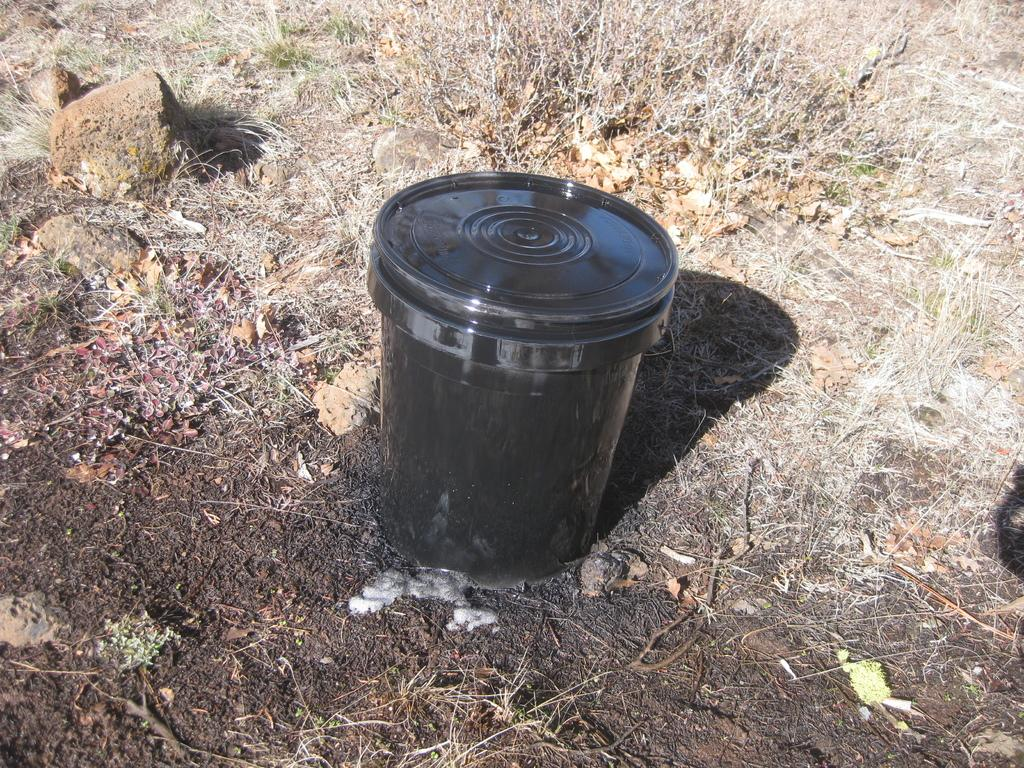What object is in the center of the image? There is a tube in the center of the image. Where is the tube positioned in the image? The tube is placed on the ground. Can you describe the tube's appearance or characteristics? Unfortunately, the provided facts do not give any information about the tube's appearance or characteristics. Is there a person in the image helping to water the plant? There is no person or plant present in the image; it only features a tube placed on the ground. 